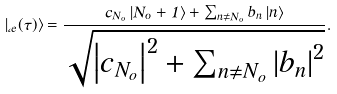Convert formula to latex. <formula><loc_0><loc_0><loc_500><loc_500>\left | \Phi _ { e } ( \tau ) \right \rangle = \frac { c _ { N _ { o } } \left | N _ { o } + 1 \right \rangle + \sum _ { n \neq N _ { o } } b _ { n } \left | n \right \rangle } { \sqrt { \left | c _ { N _ { o } } \right | ^ { 2 } + \sum _ { n \neq N _ { o } } \left | b _ { n } \right | ^ { 2 } } } .</formula> 